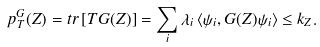Convert formula to latex. <formula><loc_0><loc_0><loc_500><loc_500>p _ { T } ^ { G } ( Z ) = t r \, [ T G ( Z ) ] = \sum _ { i } \lambda _ { i } \left \langle \psi _ { i } , G ( Z ) \psi _ { i } \right \rangle \leq k _ { Z } .</formula> 